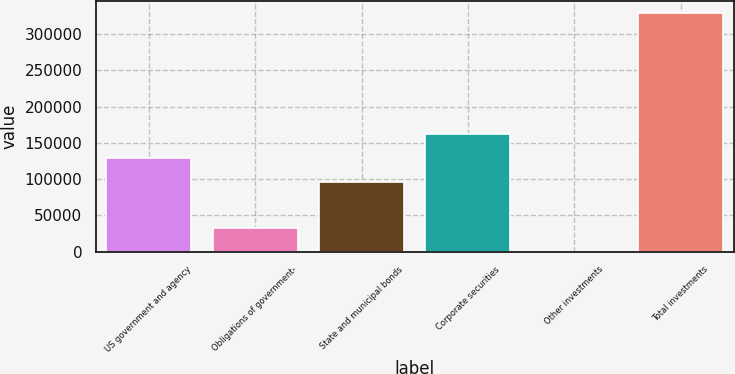Convert chart to OTSL. <chart><loc_0><loc_0><loc_500><loc_500><bar_chart><fcel>US government and agency<fcel>Obligations of government-<fcel>State and municipal bonds<fcel>Corporate securities<fcel>Other investments<fcel>Total investments<nl><fcel>129446<fcel>32965.9<fcel>96516<fcel>162376<fcel>36<fcel>329335<nl></chart> 